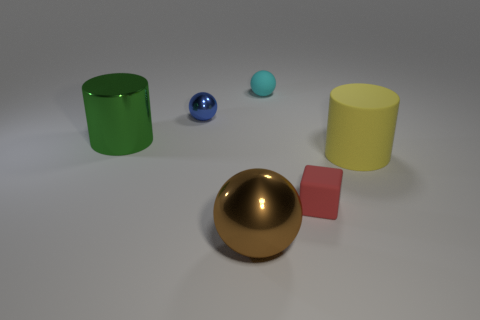Subtract all red spheres. Subtract all cyan cubes. How many spheres are left? 3 Add 1 big purple metal things. How many objects exist? 7 Subtract all cylinders. How many objects are left? 4 Add 2 blue shiny things. How many blue shiny things exist? 3 Subtract 0 green blocks. How many objects are left? 6 Subtract all matte cylinders. Subtract all big brown shiny things. How many objects are left? 4 Add 5 yellow rubber cylinders. How many yellow rubber cylinders are left? 6 